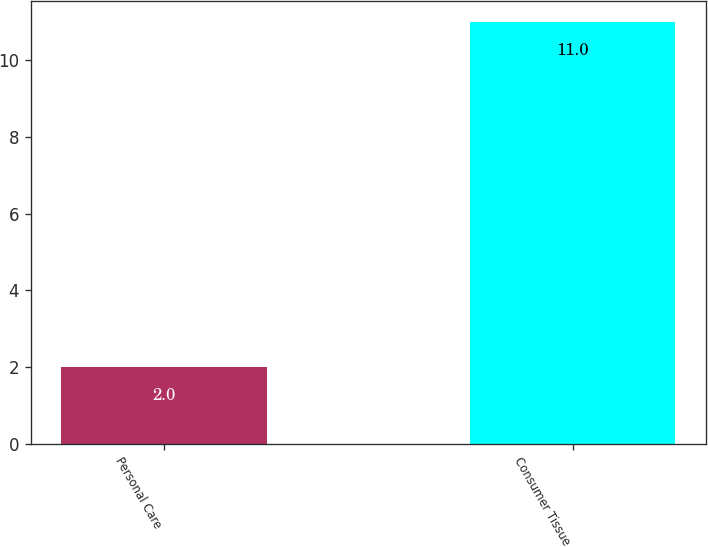Convert chart. <chart><loc_0><loc_0><loc_500><loc_500><bar_chart><fcel>Personal Care<fcel>Consumer Tissue<nl><fcel>2<fcel>11<nl></chart> 